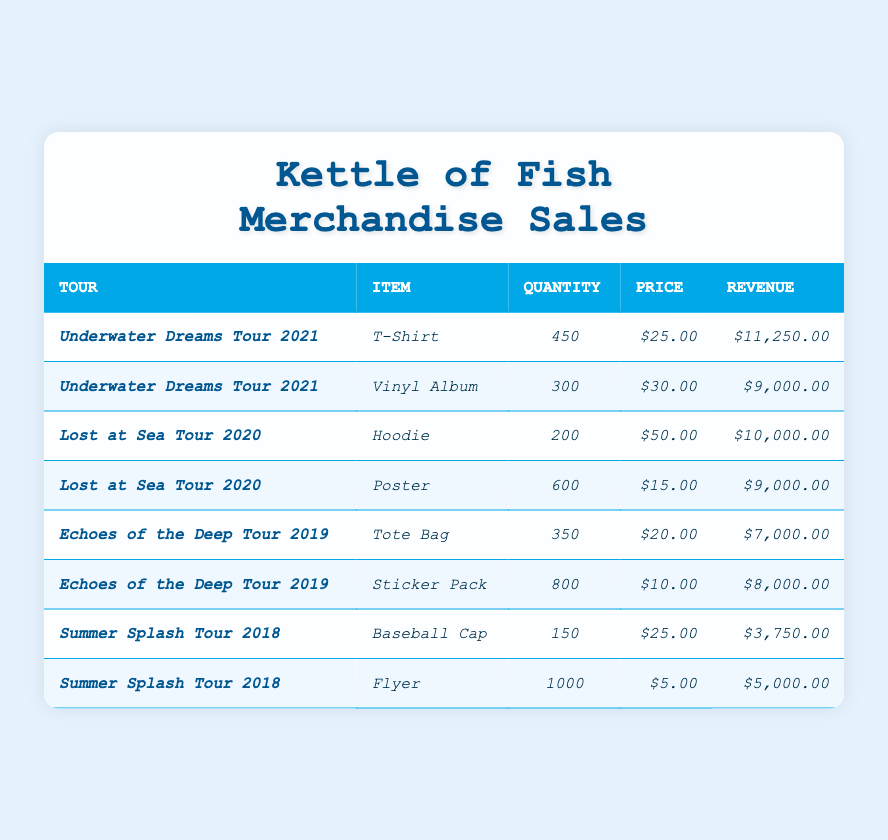What's the total revenue from merchandise sales during the *Underwater Dreams Tour 2021*? The total revenue from merchandise sales during this tour can be calculated by summing the revenue of all items sold on this tour: T-Shirt: $11,250.00 + Vinyl Album: $9,000.00 = $20,250.00.
Answer: $20,250.00 How many *Hoodies* were sold during the *Lost at Sea Tour 2020*? According to the table, the quantity sold for Hoodies during this tour is explicitly listed, which is 200.
Answer: 200 Which item generated the highest revenue in the *Echoes of the Deep Tour 2019*? By comparing the total revenue of the items from this tour, Tote Bag ($7,000.00) and Sticker Pack ($8,000.00), the Sticker Pack generated the highest revenue of $8,000.00.
Answer: Sticker Pack What is the average price of items sold during the *Summer Splash Tour 2018*? The average price is calculated by taking the sum of the prices of the items sold during the tour and dividing it by the number of items. The prices are $25.00 (Baseball Cap) and $5.00 (Flyer). The sum is $30.00, divided by 2 gives an average price of $15.00.
Answer: $15.00 Did the *Lost at Sea Tour 2020* sell more *Posters* than *Hoodies*? Yes, the quantity of Posters sold during this tour is 600, while only 200 Hoodies were sold. Thus, Posters were sold in greater quantity.
Answer: Yes What percentage of the total merchandise sales revenue did the *Flyer* contribute during the *Summer Splash Tour 2018*? To find the percentage, first calculate the total revenue for that tour: Baseball Cap: $3,750.00 + Flyer: $5,000.00 = $8,750.00. Then calculate Flyer’s percentage: ($5,000.00 / $8,750.00) * 100% = 57.14%.
Answer: 57.14% How many more *Sticker Packs* were sold compared to *Tote Bags* during the *Echoes of the Deep Tour 2019*? The quantity of Sticker Packs sold is 800, and for Tote Bags, it is 350. Therefore, the difference in sales is 800 - 350 = 450 more Sticker Packs sold.
Answer: 450 Which tour had a higher average quantity sold per item: *Underwater Dreams Tour 2021* or *Lost at Sea Tour 2020*? For the *Underwater Dreams Tour 2021*, the average quantity is (450 + 300) / 2 = 375. For the *Lost at Sea Tour 2020*, the average quantity is (200 + 600) / 2 = 400. Comparing both averages, *Lost at Sea Tour 2020* had a higher average quantity sold per item.
Answer: Lost at Sea Tour 2020 What was the total quantity of items sold in the *Underwater Dreams Tour 2021*? The total quantity sold is the sum of the quantities of all items sold: 450 (T-Shirt) + 300 (Vinyl Album) = 750.
Answer: 750 Which item had the lowest quantity sold across all tours? By looking at the quantity sold for each item, the Baseball Cap with 150 sold from the *Summer Splash Tour 2018* has the lowest quantity sold.
Answer: Baseball Cap 